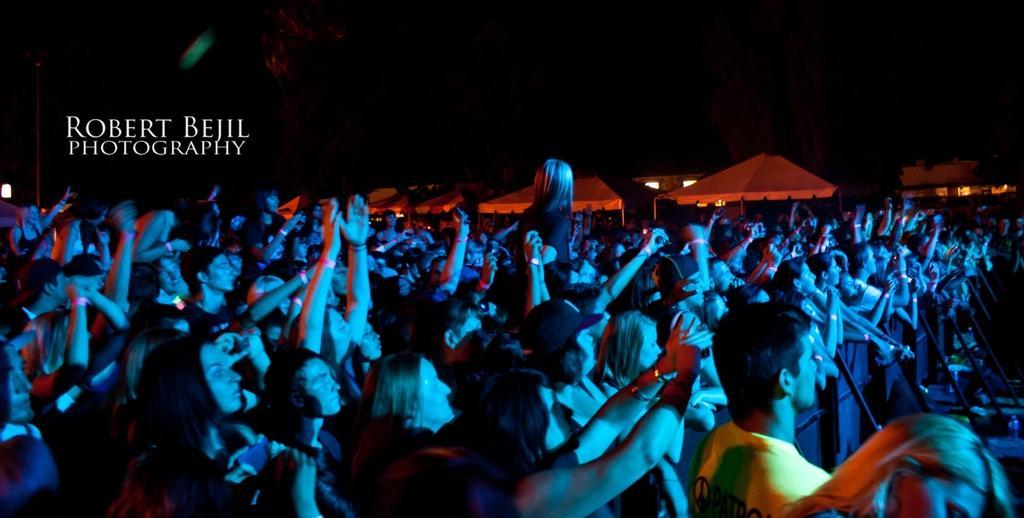Can you describe this image briefly? In this image we can see a crowd. In the back there are tents. On the left side something is written. In the background it is dark. 